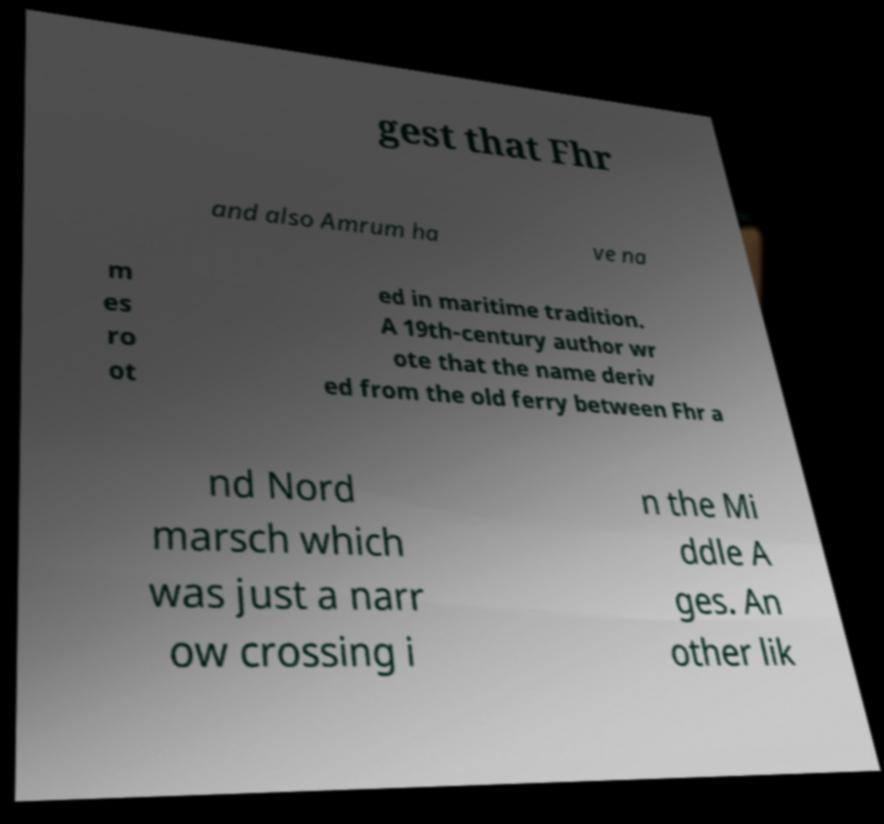Can you read and provide the text displayed in the image?This photo seems to have some interesting text. Can you extract and type it out for me? gest that Fhr and also Amrum ha ve na m es ro ot ed in maritime tradition. A 19th-century author wr ote that the name deriv ed from the old ferry between Fhr a nd Nord marsch which was just a narr ow crossing i n the Mi ddle A ges. An other lik 